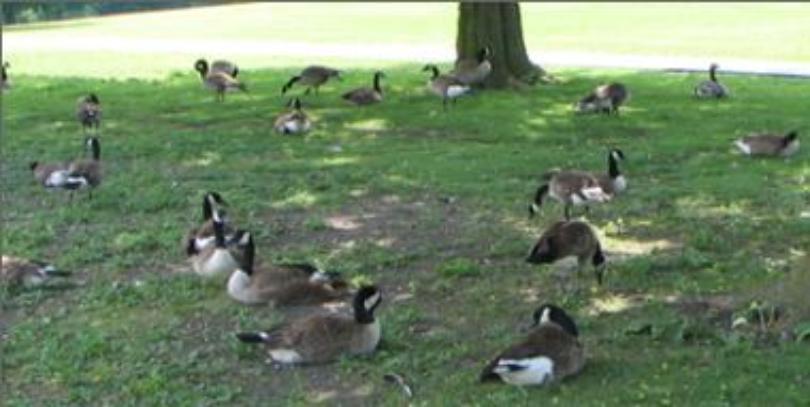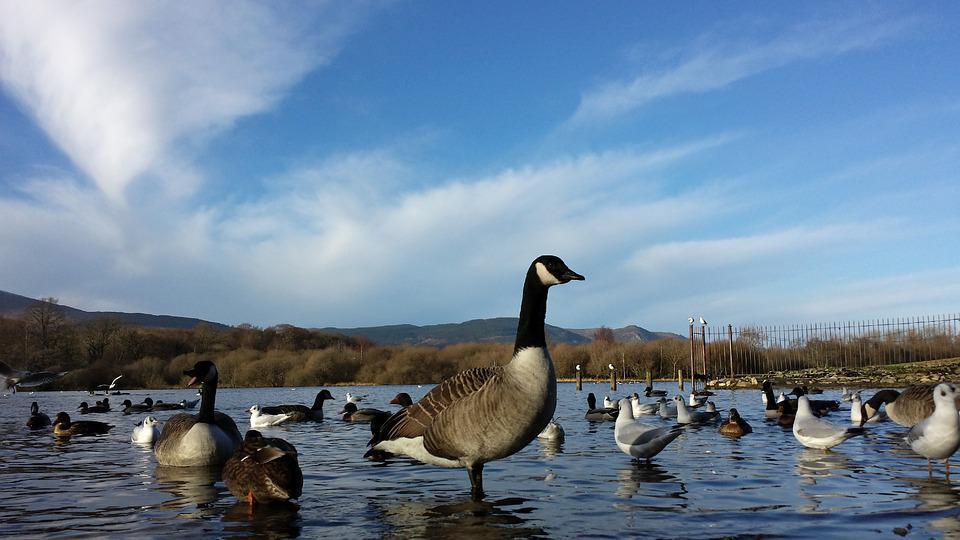The first image is the image on the left, the second image is the image on the right. Examine the images to the left and right. Is the description "the image on the right has 2 geese" accurate? Answer yes or no. No. 